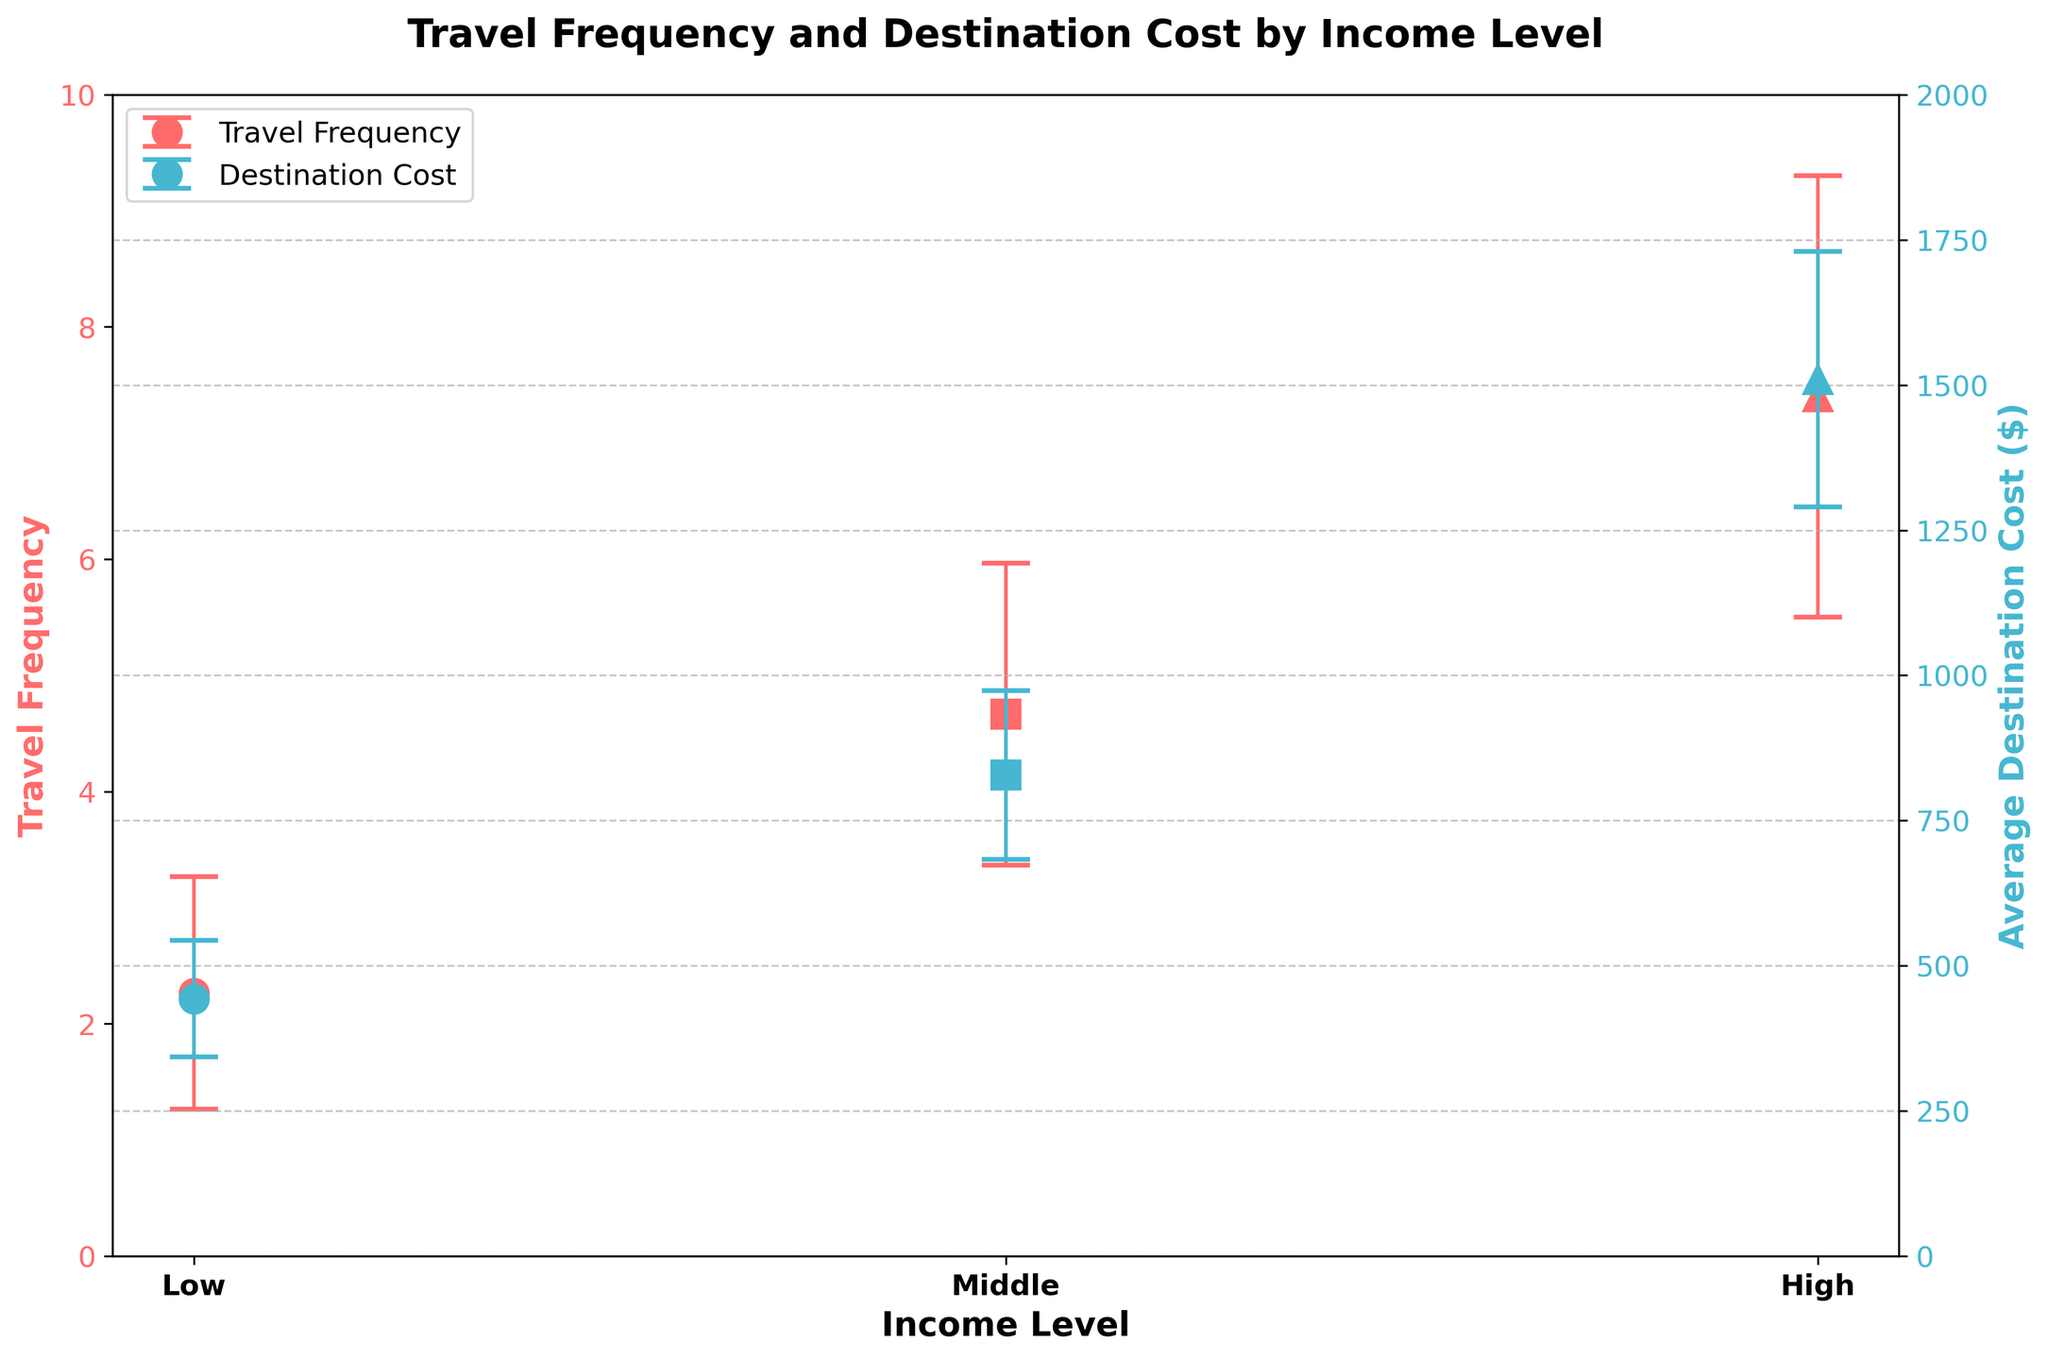What's the title of the figure? The title is usually placed at the top center of the figure and indicates the overall subject.
Answer: Travel Frequency and Destination Cost by Income Level Which income level has the highest travel frequency? Compare the heights of the markers representing travel frequency for each income level on the left y-axis. The highest marker is for High income level.
Answer: High What is the average destination cost for the middle-income level? Look at the markers on the right y-axis for the middle-income level and average their positions. The average cost is represented as $825 with error bars.
Answer: $825 How does the travel frequency of low-income and high-income levels compare? Compare the markers for travel frequency of Low and High income levels on the left y-axis. High-income travelers have a higher frequency compared to low-income travelers.
Answer: High-income is higher Which income level has the widest error bars for travel frequency? Compare the size of the error bars for travel frequency across the income levels. The High-income level has the widest error bars indicating more variability.
Answer: High What's the range of destination cost for high-income travelers? The markers for destination cost and their error bars for High-income travelers indicate the range. The average is around $1510 and the error bars suggest a variation of about ±$220.
Answer: $1280 to $1740 Are the error bars for travel frequency overlapping between middle and high-income levels? Compare the error bars from the middle and high-income levels on the left y-axis for travel frequency and see if they overlap. They do not overlap.
Answer: No What does the y-axis on the right represent? The axis on the right is labeled with "Average Destination Cost ($)" indicating it represents destination costs in dollars.
Answer: Average Destination Cost ($) Is there a noticeable trend in travel frequency as income level increases? Observe the markers representing travel frequency across income levels. Travel frequency increases as income level increases from Low to High.
Answer: Yes How much higher is the average travel frequency for high-income compared to low-income levels? Calculate the difference between the average travel frequencies of High and Low-income levels based on their markers on the left y-axis. The difference is approximately 7.4 - 2.26 = 5.14 (average value in Low income cluster).
Answer: About 5.14 